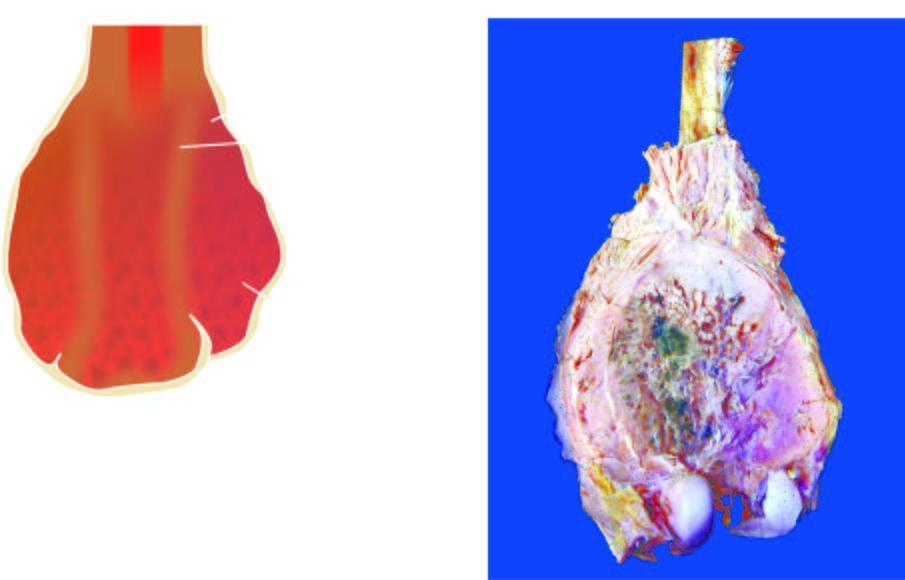what does the lower end of the femur show?
Answer the question using a single word or phrase. A bulky expanded tumour in the region of metaphysis sparing the epiphyseal cartilage 